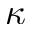Convert formula to latex. <formula><loc_0><loc_0><loc_500><loc_500>\kappa</formula> 